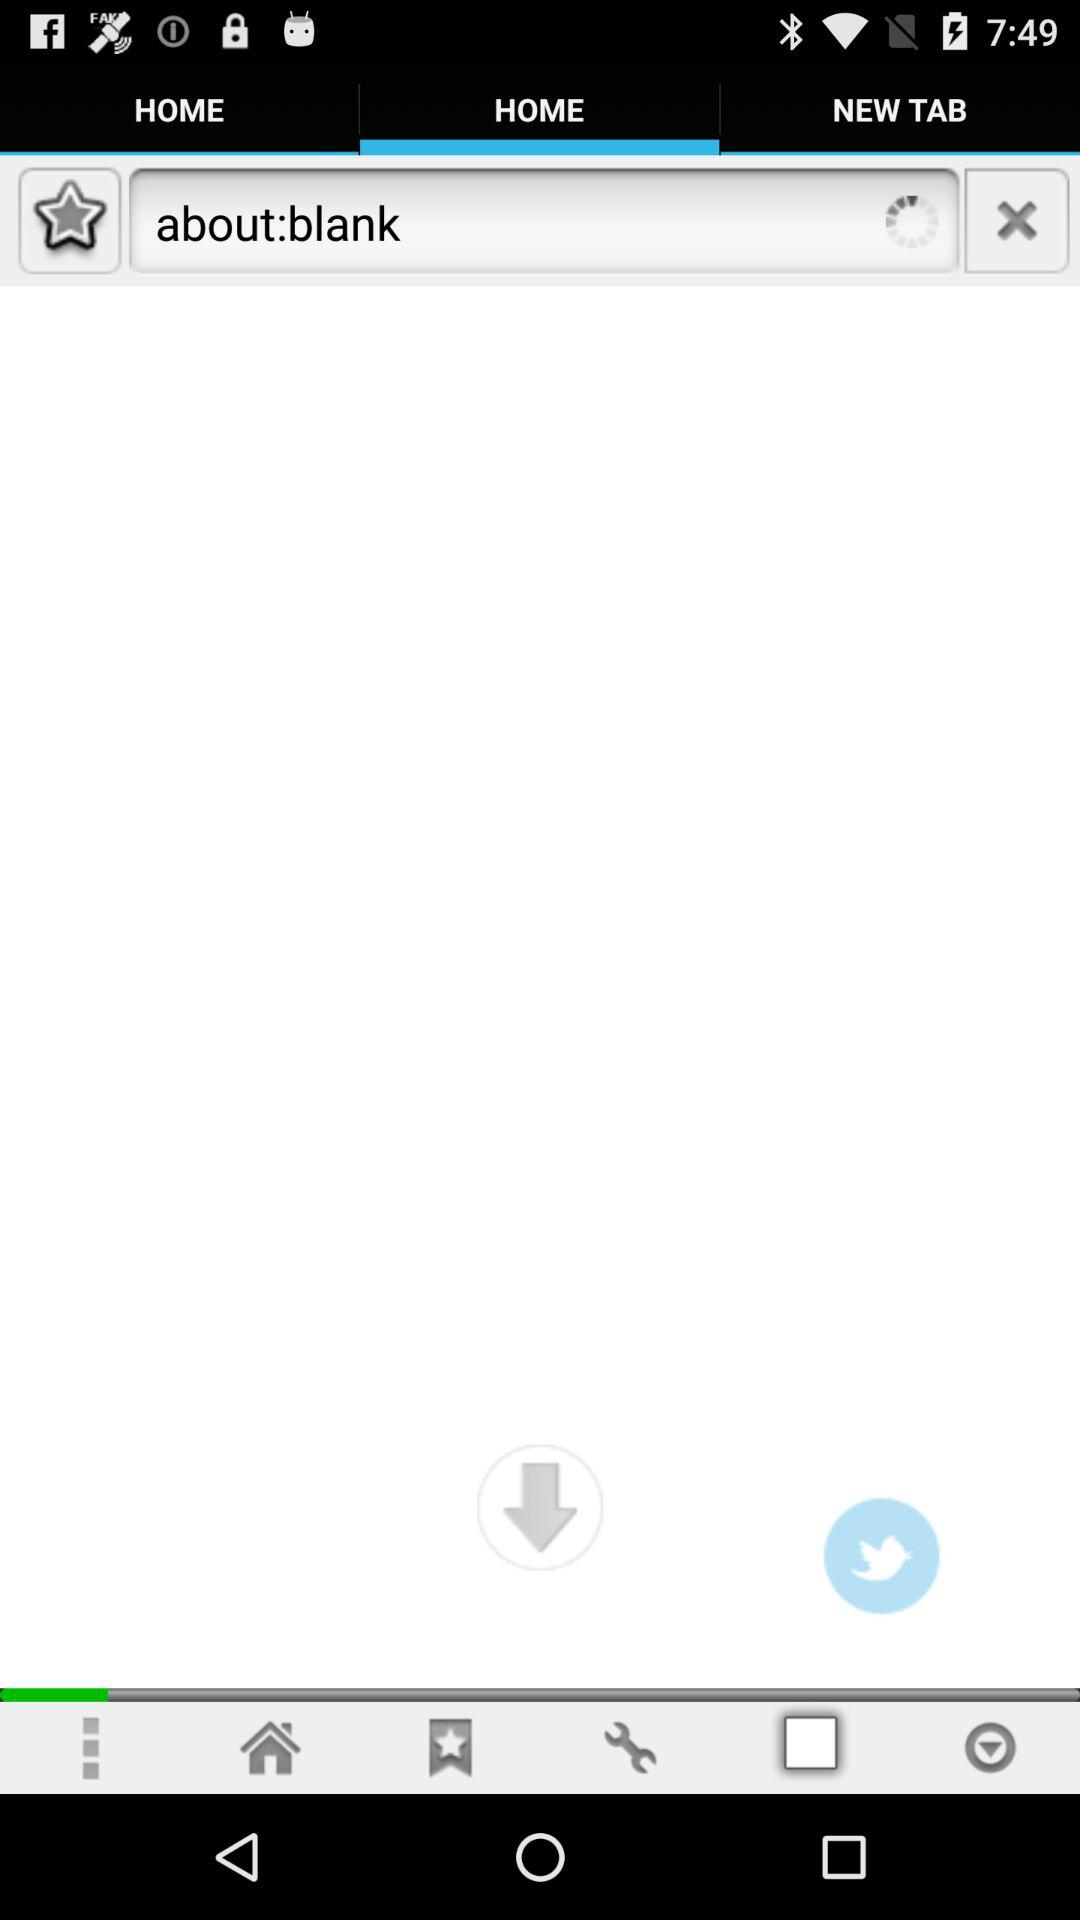Which tab has been selected? The selected tab is "HOME". 